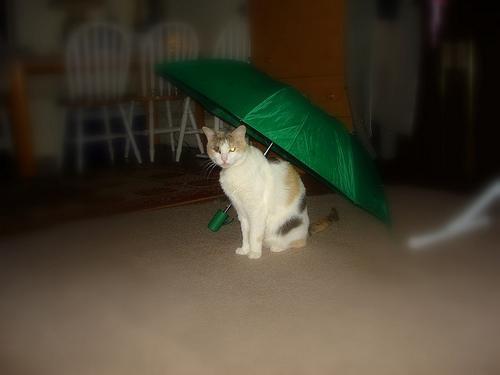How many cats?
Give a very brief answer. 1. 